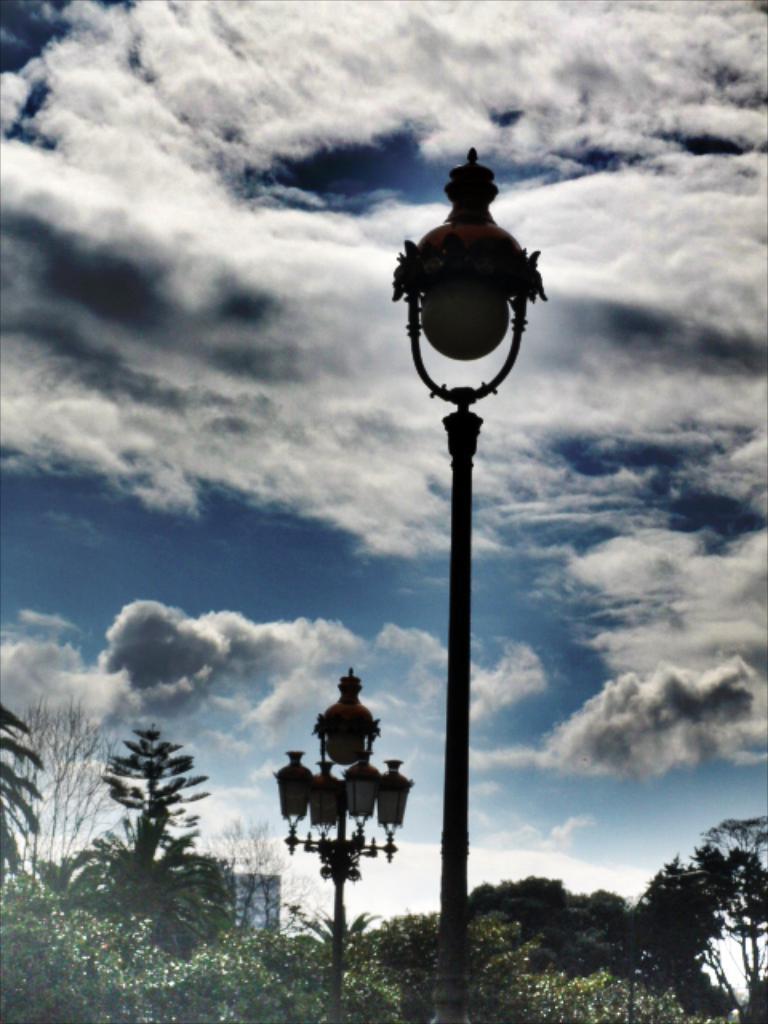In one or two sentences, can you explain what this image depicts? In this picture I can see few trees at the bottom, in the middle there are lamps. At the top there is the sky. 